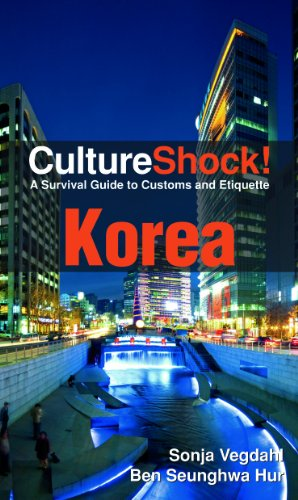Is this book related to Travel? Yes, this book is intricately related to travel as it provides essential insights and guidelines on how to culturally adapt in Korea, making it a valuable companion for travelers. 